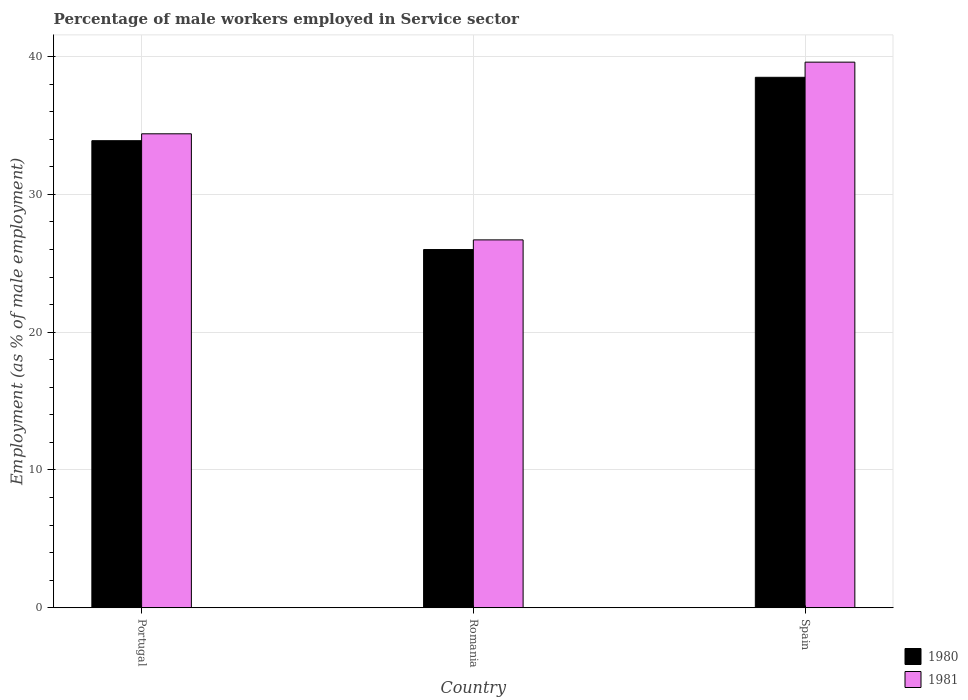Are the number of bars per tick equal to the number of legend labels?
Make the answer very short. Yes. Are the number of bars on each tick of the X-axis equal?
Your response must be concise. Yes. What is the label of the 2nd group of bars from the left?
Your answer should be compact. Romania. In how many cases, is the number of bars for a given country not equal to the number of legend labels?
Give a very brief answer. 0. What is the percentage of male workers employed in Service sector in 1981 in Romania?
Provide a succinct answer. 26.7. Across all countries, what is the maximum percentage of male workers employed in Service sector in 1981?
Offer a terse response. 39.6. Across all countries, what is the minimum percentage of male workers employed in Service sector in 1981?
Your answer should be very brief. 26.7. In which country was the percentage of male workers employed in Service sector in 1981 minimum?
Your answer should be compact. Romania. What is the total percentage of male workers employed in Service sector in 1981 in the graph?
Provide a short and direct response. 100.7. What is the difference between the percentage of male workers employed in Service sector in 1981 in Portugal and that in Romania?
Offer a very short reply. 7.7. What is the difference between the percentage of male workers employed in Service sector in 1981 in Portugal and the percentage of male workers employed in Service sector in 1980 in Romania?
Give a very brief answer. 8.4. What is the average percentage of male workers employed in Service sector in 1980 per country?
Make the answer very short. 32.8. In how many countries, is the percentage of male workers employed in Service sector in 1980 greater than 30 %?
Provide a succinct answer. 2. What is the ratio of the percentage of male workers employed in Service sector in 1981 in Romania to that in Spain?
Your answer should be very brief. 0.67. Is the difference between the percentage of male workers employed in Service sector in 1980 in Romania and Spain greater than the difference between the percentage of male workers employed in Service sector in 1981 in Romania and Spain?
Your answer should be compact. Yes. What is the difference between the highest and the second highest percentage of male workers employed in Service sector in 1981?
Offer a very short reply. 7.7. What is the difference between the highest and the lowest percentage of male workers employed in Service sector in 1981?
Your answer should be compact. 12.9. In how many countries, is the percentage of male workers employed in Service sector in 1981 greater than the average percentage of male workers employed in Service sector in 1981 taken over all countries?
Make the answer very short. 2. Is the sum of the percentage of male workers employed in Service sector in 1980 in Portugal and Spain greater than the maximum percentage of male workers employed in Service sector in 1981 across all countries?
Your answer should be very brief. Yes. What does the 1st bar from the left in Spain represents?
Offer a terse response. 1980. How many bars are there?
Provide a short and direct response. 6. What is the difference between two consecutive major ticks on the Y-axis?
Provide a short and direct response. 10. Are the values on the major ticks of Y-axis written in scientific E-notation?
Keep it short and to the point. No. Does the graph contain grids?
Ensure brevity in your answer.  Yes. How are the legend labels stacked?
Your answer should be compact. Vertical. What is the title of the graph?
Your answer should be very brief. Percentage of male workers employed in Service sector. What is the label or title of the Y-axis?
Keep it short and to the point. Employment (as % of male employment). What is the Employment (as % of male employment) of 1980 in Portugal?
Provide a succinct answer. 33.9. What is the Employment (as % of male employment) of 1981 in Portugal?
Give a very brief answer. 34.4. What is the Employment (as % of male employment) of 1980 in Romania?
Provide a succinct answer. 26. What is the Employment (as % of male employment) of 1981 in Romania?
Ensure brevity in your answer.  26.7. What is the Employment (as % of male employment) in 1980 in Spain?
Provide a succinct answer. 38.5. What is the Employment (as % of male employment) in 1981 in Spain?
Give a very brief answer. 39.6. Across all countries, what is the maximum Employment (as % of male employment) in 1980?
Offer a terse response. 38.5. Across all countries, what is the maximum Employment (as % of male employment) of 1981?
Your answer should be very brief. 39.6. Across all countries, what is the minimum Employment (as % of male employment) in 1980?
Keep it short and to the point. 26. Across all countries, what is the minimum Employment (as % of male employment) of 1981?
Your answer should be compact. 26.7. What is the total Employment (as % of male employment) in 1980 in the graph?
Ensure brevity in your answer.  98.4. What is the total Employment (as % of male employment) of 1981 in the graph?
Your answer should be compact. 100.7. What is the difference between the Employment (as % of male employment) of 1981 in Portugal and that in Romania?
Offer a terse response. 7.7. What is the difference between the Employment (as % of male employment) in 1980 in Portugal and that in Spain?
Make the answer very short. -4.6. What is the difference between the Employment (as % of male employment) of 1981 in Portugal and that in Spain?
Your answer should be compact. -5.2. What is the difference between the Employment (as % of male employment) in 1980 in Romania and that in Spain?
Provide a succinct answer. -12.5. What is the difference between the Employment (as % of male employment) of 1980 in Portugal and the Employment (as % of male employment) of 1981 in Romania?
Keep it short and to the point. 7.2. What is the average Employment (as % of male employment) of 1980 per country?
Your answer should be very brief. 32.8. What is the average Employment (as % of male employment) in 1981 per country?
Your response must be concise. 33.57. What is the difference between the Employment (as % of male employment) in 1980 and Employment (as % of male employment) in 1981 in Portugal?
Ensure brevity in your answer.  -0.5. What is the difference between the Employment (as % of male employment) in 1980 and Employment (as % of male employment) in 1981 in Romania?
Keep it short and to the point. -0.7. What is the ratio of the Employment (as % of male employment) in 1980 in Portugal to that in Romania?
Give a very brief answer. 1.3. What is the ratio of the Employment (as % of male employment) of 1981 in Portugal to that in Romania?
Provide a succinct answer. 1.29. What is the ratio of the Employment (as % of male employment) in 1980 in Portugal to that in Spain?
Offer a terse response. 0.88. What is the ratio of the Employment (as % of male employment) of 1981 in Portugal to that in Spain?
Make the answer very short. 0.87. What is the ratio of the Employment (as % of male employment) of 1980 in Romania to that in Spain?
Your answer should be compact. 0.68. What is the ratio of the Employment (as % of male employment) in 1981 in Romania to that in Spain?
Make the answer very short. 0.67. What is the difference between the highest and the lowest Employment (as % of male employment) of 1980?
Your answer should be very brief. 12.5. 